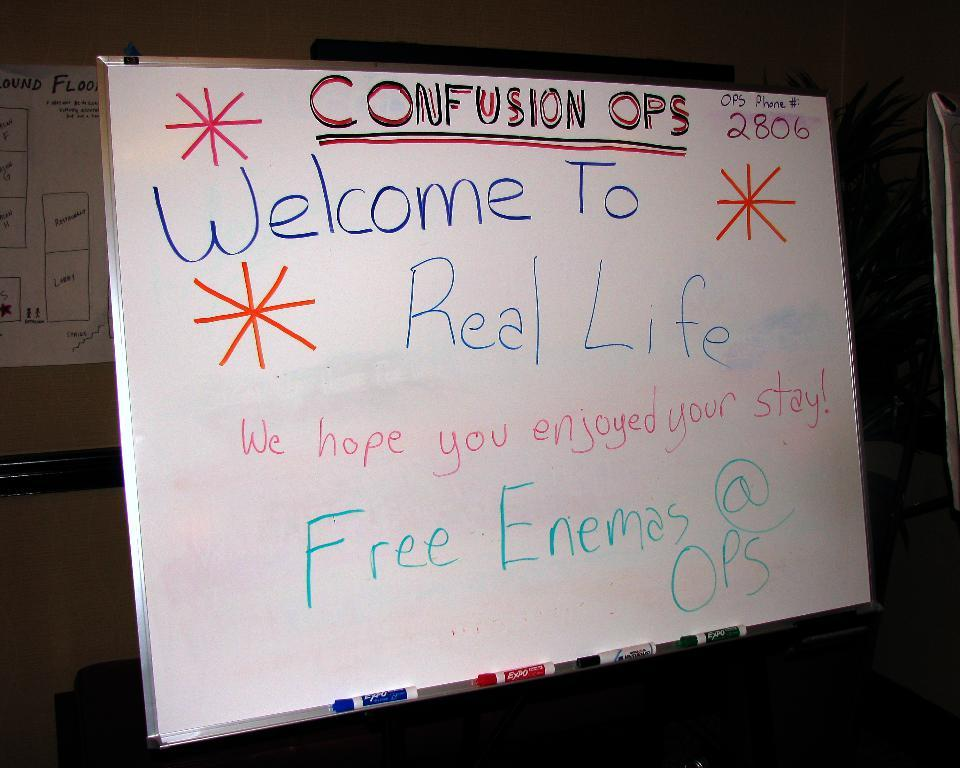<image>
Describe the image concisely. A white board has "Welcome To Real Life" written on it. 